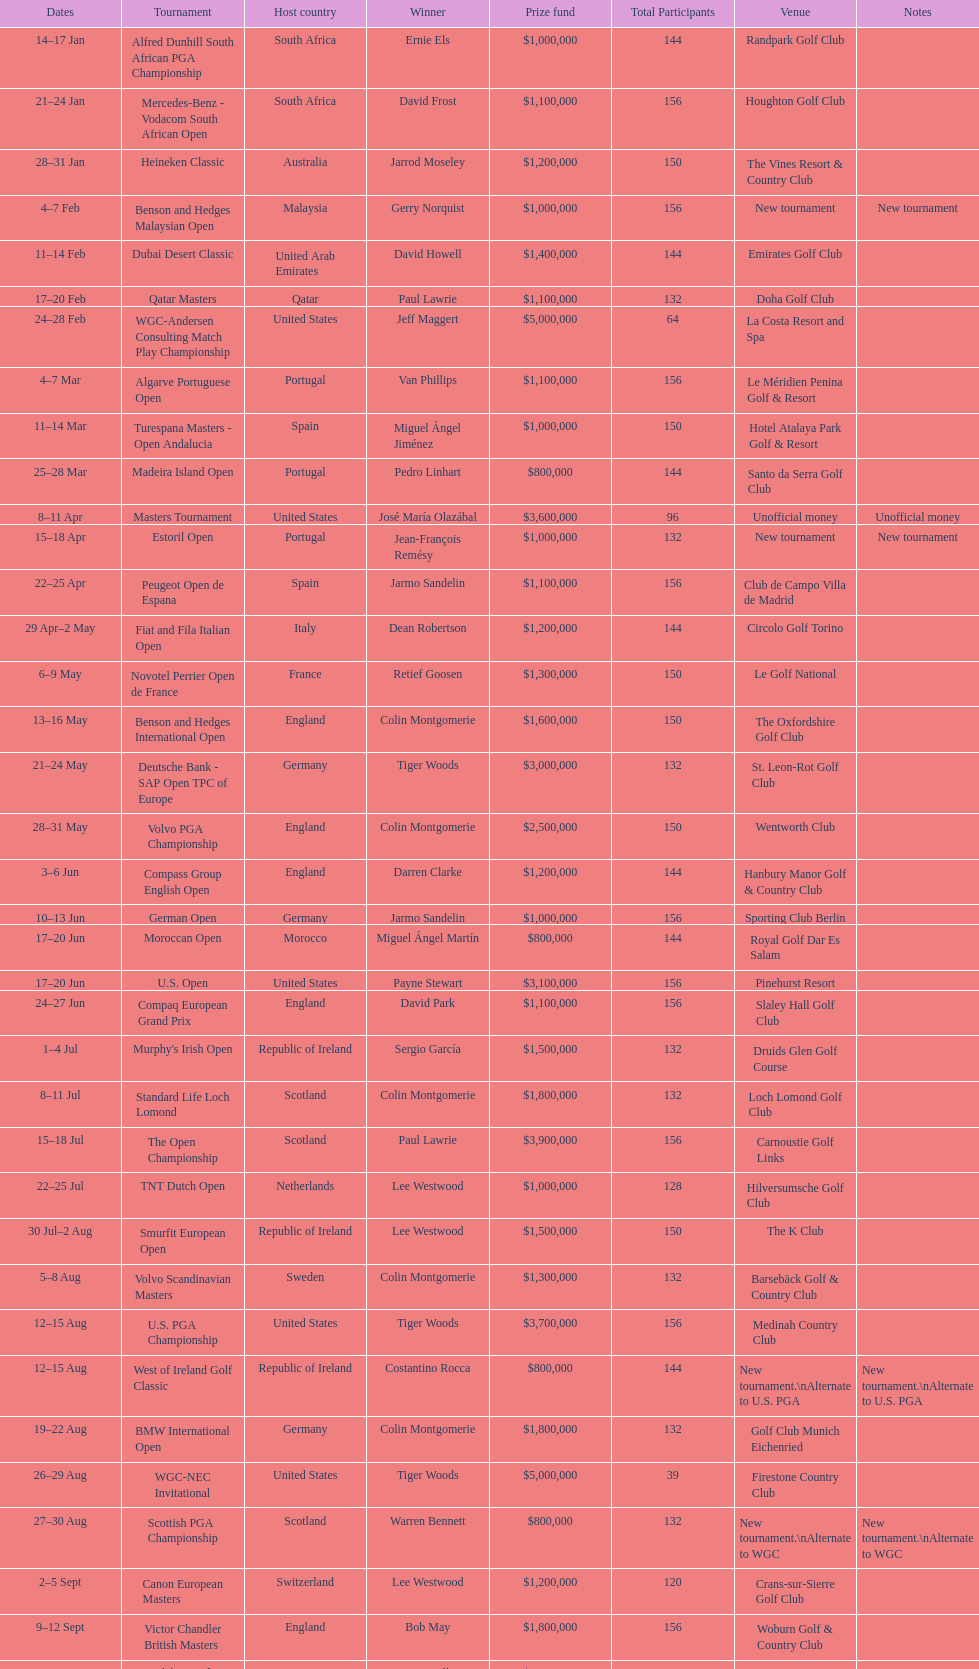Which winner won more tournaments, jeff maggert or tiger woods? Tiger Woods. 